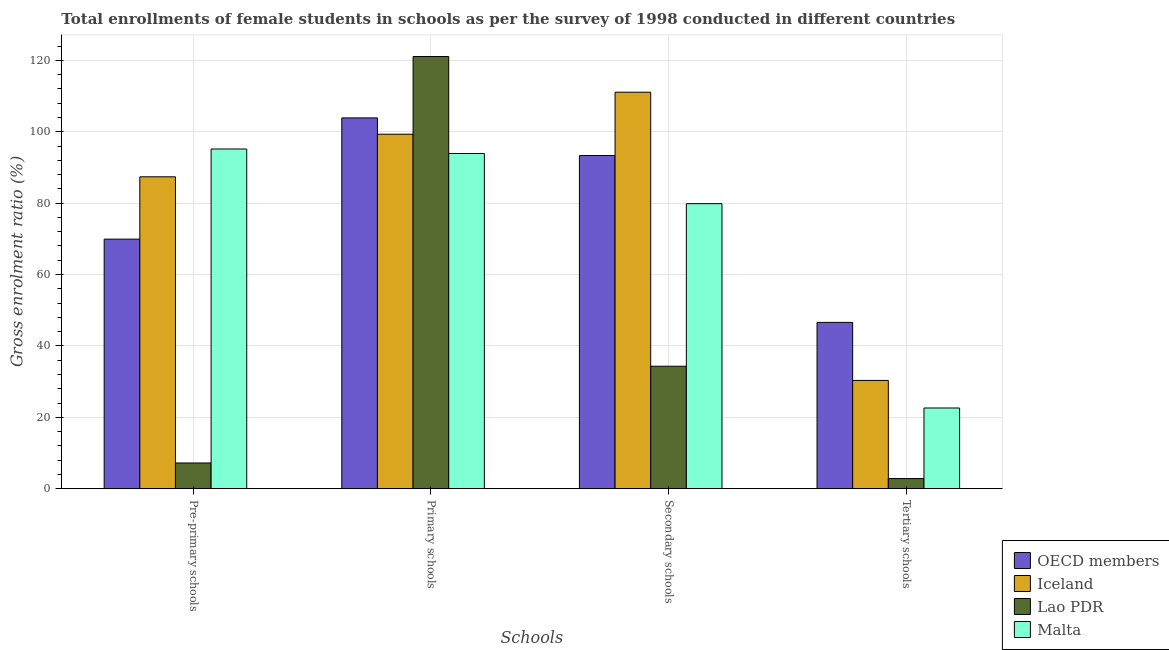How many groups of bars are there?
Offer a terse response. 4. Are the number of bars per tick equal to the number of legend labels?
Make the answer very short. Yes. Are the number of bars on each tick of the X-axis equal?
Provide a short and direct response. Yes. How many bars are there on the 4th tick from the left?
Provide a succinct answer. 4. How many bars are there on the 2nd tick from the right?
Make the answer very short. 4. What is the label of the 2nd group of bars from the left?
Your response must be concise. Primary schools. What is the gross enrolment ratio(female) in tertiary schools in Malta?
Ensure brevity in your answer.  22.6. Across all countries, what is the maximum gross enrolment ratio(female) in secondary schools?
Offer a terse response. 111.07. Across all countries, what is the minimum gross enrolment ratio(female) in tertiary schools?
Keep it short and to the point. 2.84. In which country was the gross enrolment ratio(female) in pre-primary schools maximum?
Offer a very short reply. Malta. In which country was the gross enrolment ratio(female) in primary schools minimum?
Your response must be concise. Malta. What is the total gross enrolment ratio(female) in primary schools in the graph?
Your answer should be compact. 418.17. What is the difference between the gross enrolment ratio(female) in tertiary schools in OECD members and that in Lao PDR?
Give a very brief answer. 43.74. What is the difference between the gross enrolment ratio(female) in pre-primary schools in OECD members and the gross enrolment ratio(female) in tertiary schools in Iceland?
Your response must be concise. 39.58. What is the average gross enrolment ratio(female) in primary schools per country?
Keep it short and to the point. 104.54. What is the difference between the gross enrolment ratio(female) in secondary schools and gross enrolment ratio(female) in tertiary schools in Malta?
Ensure brevity in your answer.  57.24. In how many countries, is the gross enrolment ratio(female) in tertiary schools greater than 88 %?
Your answer should be compact. 0. What is the ratio of the gross enrolment ratio(female) in primary schools in OECD members to that in Lao PDR?
Keep it short and to the point. 0.86. Is the gross enrolment ratio(female) in primary schools in Lao PDR less than that in Malta?
Keep it short and to the point. No. Is the difference between the gross enrolment ratio(female) in tertiary schools in Iceland and Malta greater than the difference between the gross enrolment ratio(female) in secondary schools in Iceland and Malta?
Make the answer very short. No. What is the difference between the highest and the second highest gross enrolment ratio(female) in tertiary schools?
Keep it short and to the point. 16.25. What is the difference between the highest and the lowest gross enrolment ratio(female) in secondary schools?
Make the answer very short. 76.77. Is it the case that in every country, the sum of the gross enrolment ratio(female) in tertiary schools and gross enrolment ratio(female) in secondary schools is greater than the sum of gross enrolment ratio(female) in pre-primary schools and gross enrolment ratio(female) in primary schools?
Ensure brevity in your answer.  No. What does the 2nd bar from the right in Pre-primary schools represents?
Provide a succinct answer. Lao PDR. Is it the case that in every country, the sum of the gross enrolment ratio(female) in pre-primary schools and gross enrolment ratio(female) in primary schools is greater than the gross enrolment ratio(female) in secondary schools?
Offer a very short reply. Yes. How many bars are there?
Provide a short and direct response. 16. What is the difference between two consecutive major ticks on the Y-axis?
Make the answer very short. 20. Are the values on the major ticks of Y-axis written in scientific E-notation?
Keep it short and to the point. No. Does the graph contain any zero values?
Make the answer very short. No. Where does the legend appear in the graph?
Offer a very short reply. Bottom right. How many legend labels are there?
Ensure brevity in your answer.  4. What is the title of the graph?
Make the answer very short. Total enrollments of female students in schools as per the survey of 1998 conducted in different countries. Does "Sierra Leone" appear as one of the legend labels in the graph?
Make the answer very short. No. What is the label or title of the X-axis?
Offer a terse response. Schools. What is the Gross enrolment ratio (%) in OECD members in Pre-primary schools?
Provide a short and direct response. 69.91. What is the Gross enrolment ratio (%) of Iceland in Pre-primary schools?
Ensure brevity in your answer.  87.37. What is the Gross enrolment ratio (%) in Lao PDR in Pre-primary schools?
Keep it short and to the point. 7.2. What is the Gross enrolment ratio (%) of Malta in Pre-primary schools?
Ensure brevity in your answer.  95.16. What is the Gross enrolment ratio (%) in OECD members in Primary schools?
Your response must be concise. 103.88. What is the Gross enrolment ratio (%) of Iceland in Primary schools?
Ensure brevity in your answer.  99.3. What is the Gross enrolment ratio (%) of Lao PDR in Primary schools?
Keep it short and to the point. 121.08. What is the Gross enrolment ratio (%) in Malta in Primary schools?
Your response must be concise. 93.9. What is the Gross enrolment ratio (%) of OECD members in Secondary schools?
Your answer should be very brief. 93.33. What is the Gross enrolment ratio (%) of Iceland in Secondary schools?
Provide a short and direct response. 111.07. What is the Gross enrolment ratio (%) in Lao PDR in Secondary schools?
Give a very brief answer. 34.3. What is the Gross enrolment ratio (%) in Malta in Secondary schools?
Provide a short and direct response. 79.85. What is the Gross enrolment ratio (%) of OECD members in Tertiary schools?
Give a very brief answer. 46.58. What is the Gross enrolment ratio (%) of Iceland in Tertiary schools?
Provide a short and direct response. 30.33. What is the Gross enrolment ratio (%) of Lao PDR in Tertiary schools?
Give a very brief answer. 2.84. What is the Gross enrolment ratio (%) of Malta in Tertiary schools?
Give a very brief answer. 22.6. Across all Schools, what is the maximum Gross enrolment ratio (%) in OECD members?
Provide a succinct answer. 103.88. Across all Schools, what is the maximum Gross enrolment ratio (%) in Iceland?
Provide a succinct answer. 111.07. Across all Schools, what is the maximum Gross enrolment ratio (%) of Lao PDR?
Offer a very short reply. 121.08. Across all Schools, what is the maximum Gross enrolment ratio (%) of Malta?
Your answer should be very brief. 95.16. Across all Schools, what is the minimum Gross enrolment ratio (%) of OECD members?
Offer a very short reply. 46.58. Across all Schools, what is the minimum Gross enrolment ratio (%) in Iceland?
Offer a terse response. 30.33. Across all Schools, what is the minimum Gross enrolment ratio (%) of Lao PDR?
Your response must be concise. 2.84. Across all Schools, what is the minimum Gross enrolment ratio (%) of Malta?
Offer a very short reply. 22.6. What is the total Gross enrolment ratio (%) of OECD members in the graph?
Provide a succinct answer. 313.7. What is the total Gross enrolment ratio (%) in Iceland in the graph?
Keep it short and to the point. 328.07. What is the total Gross enrolment ratio (%) in Lao PDR in the graph?
Give a very brief answer. 165.42. What is the total Gross enrolment ratio (%) of Malta in the graph?
Your response must be concise. 291.52. What is the difference between the Gross enrolment ratio (%) of OECD members in Pre-primary schools and that in Primary schools?
Your response must be concise. -33.97. What is the difference between the Gross enrolment ratio (%) in Iceland in Pre-primary schools and that in Primary schools?
Your answer should be very brief. -11.93. What is the difference between the Gross enrolment ratio (%) of Lao PDR in Pre-primary schools and that in Primary schools?
Provide a succinct answer. -113.88. What is the difference between the Gross enrolment ratio (%) in Malta in Pre-primary schools and that in Primary schools?
Ensure brevity in your answer.  1.26. What is the difference between the Gross enrolment ratio (%) of OECD members in Pre-primary schools and that in Secondary schools?
Offer a very short reply. -23.42. What is the difference between the Gross enrolment ratio (%) of Iceland in Pre-primary schools and that in Secondary schools?
Give a very brief answer. -23.7. What is the difference between the Gross enrolment ratio (%) in Lao PDR in Pre-primary schools and that in Secondary schools?
Your answer should be compact. -27.1. What is the difference between the Gross enrolment ratio (%) in Malta in Pre-primary schools and that in Secondary schools?
Provide a succinct answer. 15.32. What is the difference between the Gross enrolment ratio (%) in OECD members in Pre-primary schools and that in Tertiary schools?
Provide a short and direct response. 23.33. What is the difference between the Gross enrolment ratio (%) in Iceland in Pre-primary schools and that in Tertiary schools?
Make the answer very short. 57.04. What is the difference between the Gross enrolment ratio (%) of Lao PDR in Pre-primary schools and that in Tertiary schools?
Make the answer very short. 4.36. What is the difference between the Gross enrolment ratio (%) in Malta in Pre-primary schools and that in Tertiary schools?
Your answer should be compact. 72.56. What is the difference between the Gross enrolment ratio (%) of OECD members in Primary schools and that in Secondary schools?
Ensure brevity in your answer.  10.55. What is the difference between the Gross enrolment ratio (%) of Iceland in Primary schools and that in Secondary schools?
Provide a succinct answer. -11.77. What is the difference between the Gross enrolment ratio (%) in Lao PDR in Primary schools and that in Secondary schools?
Give a very brief answer. 86.78. What is the difference between the Gross enrolment ratio (%) in Malta in Primary schools and that in Secondary schools?
Make the answer very short. 14.06. What is the difference between the Gross enrolment ratio (%) of OECD members in Primary schools and that in Tertiary schools?
Your answer should be compact. 57.29. What is the difference between the Gross enrolment ratio (%) in Iceland in Primary schools and that in Tertiary schools?
Keep it short and to the point. 68.98. What is the difference between the Gross enrolment ratio (%) in Lao PDR in Primary schools and that in Tertiary schools?
Ensure brevity in your answer.  118.24. What is the difference between the Gross enrolment ratio (%) of Malta in Primary schools and that in Tertiary schools?
Provide a short and direct response. 71.3. What is the difference between the Gross enrolment ratio (%) of OECD members in Secondary schools and that in Tertiary schools?
Offer a very short reply. 46.75. What is the difference between the Gross enrolment ratio (%) of Iceland in Secondary schools and that in Tertiary schools?
Give a very brief answer. 80.74. What is the difference between the Gross enrolment ratio (%) in Lao PDR in Secondary schools and that in Tertiary schools?
Give a very brief answer. 31.47. What is the difference between the Gross enrolment ratio (%) in Malta in Secondary schools and that in Tertiary schools?
Your answer should be compact. 57.24. What is the difference between the Gross enrolment ratio (%) of OECD members in Pre-primary schools and the Gross enrolment ratio (%) of Iceland in Primary schools?
Give a very brief answer. -29.4. What is the difference between the Gross enrolment ratio (%) in OECD members in Pre-primary schools and the Gross enrolment ratio (%) in Lao PDR in Primary schools?
Provide a short and direct response. -51.17. What is the difference between the Gross enrolment ratio (%) in OECD members in Pre-primary schools and the Gross enrolment ratio (%) in Malta in Primary schools?
Provide a short and direct response. -24. What is the difference between the Gross enrolment ratio (%) of Iceland in Pre-primary schools and the Gross enrolment ratio (%) of Lao PDR in Primary schools?
Provide a succinct answer. -33.71. What is the difference between the Gross enrolment ratio (%) of Iceland in Pre-primary schools and the Gross enrolment ratio (%) of Malta in Primary schools?
Your answer should be very brief. -6.53. What is the difference between the Gross enrolment ratio (%) of Lao PDR in Pre-primary schools and the Gross enrolment ratio (%) of Malta in Primary schools?
Your answer should be compact. -86.7. What is the difference between the Gross enrolment ratio (%) of OECD members in Pre-primary schools and the Gross enrolment ratio (%) of Iceland in Secondary schools?
Provide a succinct answer. -41.16. What is the difference between the Gross enrolment ratio (%) in OECD members in Pre-primary schools and the Gross enrolment ratio (%) in Lao PDR in Secondary schools?
Your answer should be very brief. 35.61. What is the difference between the Gross enrolment ratio (%) of OECD members in Pre-primary schools and the Gross enrolment ratio (%) of Malta in Secondary schools?
Offer a very short reply. -9.94. What is the difference between the Gross enrolment ratio (%) in Iceland in Pre-primary schools and the Gross enrolment ratio (%) in Lao PDR in Secondary schools?
Keep it short and to the point. 53.07. What is the difference between the Gross enrolment ratio (%) in Iceland in Pre-primary schools and the Gross enrolment ratio (%) in Malta in Secondary schools?
Your answer should be compact. 7.52. What is the difference between the Gross enrolment ratio (%) of Lao PDR in Pre-primary schools and the Gross enrolment ratio (%) of Malta in Secondary schools?
Offer a very short reply. -72.65. What is the difference between the Gross enrolment ratio (%) of OECD members in Pre-primary schools and the Gross enrolment ratio (%) of Iceland in Tertiary schools?
Offer a very short reply. 39.58. What is the difference between the Gross enrolment ratio (%) of OECD members in Pre-primary schools and the Gross enrolment ratio (%) of Lao PDR in Tertiary schools?
Offer a terse response. 67.07. What is the difference between the Gross enrolment ratio (%) in OECD members in Pre-primary schools and the Gross enrolment ratio (%) in Malta in Tertiary schools?
Keep it short and to the point. 47.31. What is the difference between the Gross enrolment ratio (%) of Iceland in Pre-primary schools and the Gross enrolment ratio (%) of Lao PDR in Tertiary schools?
Give a very brief answer. 84.53. What is the difference between the Gross enrolment ratio (%) in Iceland in Pre-primary schools and the Gross enrolment ratio (%) in Malta in Tertiary schools?
Give a very brief answer. 64.77. What is the difference between the Gross enrolment ratio (%) of Lao PDR in Pre-primary schools and the Gross enrolment ratio (%) of Malta in Tertiary schools?
Make the answer very short. -15.4. What is the difference between the Gross enrolment ratio (%) of OECD members in Primary schools and the Gross enrolment ratio (%) of Iceland in Secondary schools?
Offer a very short reply. -7.19. What is the difference between the Gross enrolment ratio (%) of OECD members in Primary schools and the Gross enrolment ratio (%) of Lao PDR in Secondary schools?
Make the answer very short. 69.57. What is the difference between the Gross enrolment ratio (%) in OECD members in Primary schools and the Gross enrolment ratio (%) in Malta in Secondary schools?
Your answer should be compact. 24.03. What is the difference between the Gross enrolment ratio (%) of Iceland in Primary schools and the Gross enrolment ratio (%) of Lao PDR in Secondary schools?
Provide a short and direct response. 65. What is the difference between the Gross enrolment ratio (%) of Iceland in Primary schools and the Gross enrolment ratio (%) of Malta in Secondary schools?
Provide a succinct answer. 19.46. What is the difference between the Gross enrolment ratio (%) in Lao PDR in Primary schools and the Gross enrolment ratio (%) in Malta in Secondary schools?
Make the answer very short. 41.23. What is the difference between the Gross enrolment ratio (%) in OECD members in Primary schools and the Gross enrolment ratio (%) in Iceland in Tertiary schools?
Offer a very short reply. 73.55. What is the difference between the Gross enrolment ratio (%) in OECD members in Primary schools and the Gross enrolment ratio (%) in Lao PDR in Tertiary schools?
Provide a short and direct response. 101.04. What is the difference between the Gross enrolment ratio (%) in OECD members in Primary schools and the Gross enrolment ratio (%) in Malta in Tertiary schools?
Your response must be concise. 81.27. What is the difference between the Gross enrolment ratio (%) in Iceland in Primary schools and the Gross enrolment ratio (%) in Lao PDR in Tertiary schools?
Give a very brief answer. 96.47. What is the difference between the Gross enrolment ratio (%) of Iceland in Primary schools and the Gross enrolment ratio (%) of Malta in Tertiary schools?
Your response must be concise. 76.7. What is the difference between the Gross enrolment ratio (%) of Lao PDR in Primary schools and the Gross enrolment ratio (%) of Malta in Tertiary schools?
Offer a terse response. 98.48. What is the difference between the Gross enrolment ratio (%) of OECD members in Secondary schools and the Gross enrolment ratio (%) of Iceland in Tertiary schools?
Your answer should be compact. 63. What is the difference between the Gross enrolment ratio (%) of OECD members in Secondary schools and the Gross enrolment ratio (%) of Lao PDR in Tertiary schools?
Keep it short and to the point. 90.49. What is the difference between the Gross enrolment ratio (%) in OECD members in Secondary schools and the Gross enrolment ratio (%) in Malta in Tertiary schools?
Keep it short and to the point. 70.73. What is the difference between the Gross enrolment ratio (%) of Iceland in Secondary schools and the Gross enrolment ratio (%) of Lao PDR in Tertiary schools?
Your response must be concise. 108.23. What is the difference between the Gross enrolment ratio (%) of Iceland in Secondary schools and the Gross enrolment ratio (%) of Malta in Tertiary schools?
Your answer should be compact. 88.47. What is the difference between the Gross enrolment ratio (%) of Lao PDR in Secondary schools and the Gross enrolment ratio (%) of Malta in Tertiary schools?
Provide a succinct answer. 11.7. What is the average Gross enrolment ratio (%) of OECD members per Schools?
Offer a terse response. 78.42. What is the average Gross enrolment ratio (%) of Iceland per Schools?
Offer a very short reply. 82.02. What is the average Gross enrolment ratio (%) in Lao PDR per Schools?
Offer a very short reply. 41.36. What is the average Gross enrolment ratio (%) in Malta per Schools?
Offer a very short reply. 72.88. What is the difference between the Gross enrolment ratio (%) of OECD members and Gross enrolment ratio (%) of Iceland in Pre-primary schools?
Keep it short and to the point. -17.46. What is the difference between the Gross enrolment ratio (%) of OECD members and Gross enrolment ratio (%) of Lao PDR in Pre-primary schools?
Make the answer very short. 62.71. What is the difference between the Gross enrolment ratio (%) in OECD members and Gross enrolment ratio (%) in Malta in Pre-primary schools?
Provide a succinct answer. -25.25. What is the difference between the Gross enrolment ratio (%) in Iceland and Gross enrolment ratio (%) in Lao PDR in Pre-primary schools?
Ensure brevity in your answer.  80.17. What is the difference between the Gross enrolment ratio (%) of Iceland and Gross enrolment ratio (%) of Malta in Pre-primary schools?
Give a very brief answer. -7.79. What is the difference between the Gross enrolment ratio (%) of Lao PDR and Gross enrolment ratio (%) of Malta in Pre-primary schools?
Ensure brevity in your answer.  -87.96. What is the difference between the Gross enrolment ratio (%) in OECD members and Gross enrolment ratio (%) in Iceland in Primary schools?
Provide a succinct answer. 4.57. What is the difference between the Gross enrolment ratio (%) in OECD members and Gross enrolment ratio (%) in Lao PDR in Primary schools?
Give a very brief answer. -17.2. What is the difference between the Gross enrolment ratio (%) in OECD members and Gross enrolment ratio (%) in Malta in Primary schools?
Offer a very short reply. 9.97. What is the difference between the Gross enrolment ratio (%) in Iceland and Gross enrolment ratio (%) in Lao PDR in Primary schools?
Your answer should be compact. -21.78. What is the difference between the Gross enrolment ratio (%) of Iceland and Gross enrolment ratio (%) of Malta in Primary schools?
Ensure brevity in your answer.  5.4. What is the difference between the Gross enrolment ratio (%) of Lao PDR and Gross enrolment ratio (%) of Malta in Primary schools?
Make the answer very short. 27.18. What is the difference between the Gross enrolment ratio (%) in OECD members and Gross enrolment ratio (%) in Iceland in Secondary schools?
Provide a short and direct response. -17.74. What is the difference between the Gross enrolment ratio (%) in OECD members and Gross enrolment ratio (%) in Lao PDR in Secondary schools?
Your answer should be very brief. 59.02. What is the difference between the Gross enrolment ratio (%) in OECD members and Gross enrolment ratio (%) in Malta in Secondary schools?
Give a very brief answer. 13.48. What is the difference between the Gross enrolment ratio (%) in Iceland and Gross enrolment ratio (%) in Lao PDR in Secondary schools?
Provide a succinct answer. 76.77. What is the difference between the Gross enrolment ratio (%) of Iceland and Gross enrolment ratio (%) of Malta in Secondary schools?
Ensure brevity in your answer.  31.22. What is the difference between the Gross enrolment ratio (%) in Lao PDR and Gross enrolment ratio (%) in Malta in Secondary schools?
Give a very brief answer. -45.54. What is the difference between the Gross enrolment ratio (%) of OECD members and Gross enrolment ratio (%) of Iceland in Tertiary schools?
Your answer should be compact. 16.25. What is the difference between the Gross enrolment ratio (%) in OECD members and Gross enrolment ratio (%) in Lao PDR in Tertiary schools?
Provide a succinct answer. 43.74. What is the difference between the Gross enrolment ratio (%) in OECD members and Gross enrolment ratio (%) in Malta in Tertiary schools?
Provide a succinct answer. 23.98. What is the difference between the Gross enrolment ratio (%) in Iceland and Gross enrolment ratio (%) in Lao PDR in Tertiary schools?
Give a very brief answer. 27.49. What is the difference between the Gross enrolment ratio (%) in Iceland and Gross enrolment ratio (%) in Malta in Tertiary schools?
Keep it short and to the point. 7.72. What is the difference between the Gross enrolment ratio (%) of Lao PDR and Gross enrolment ratio (%) of Malta in Tertiary schools?
Your answer should be very brief. -19.77. What is the ratio of the Gross enrolment ratio (%) in OECD members in Pre-primary schools to that in Primary schools?
Keep it short and to the point. 0.67. What is the ratio of the Gross enrolment ratio (%) in Iceland in Pre-primary schools to that in Primary schools?
Your answer should be very brief. 0.88. What is the ratio of the Gross enrolment ratio (%) in Lao PDR in Pre-primary schools to that in Primary schools?
Provide a succinct answer. 0.06. What is the ratio of the Gross enrolment ratio (%) in Malta in Pre-primary schools to that in Primary schools?
Your response must be concise. 1.01. What is the ratio of the Gross enrolment ratio (%) in OECD members in Pre-primary schools to that in Secondary schools?
Your answer should be compact. 0.75. What is the ratio of the Gross enrolment ratio (%) of Iceland in Pre-primary schools to that in Secondary schools?
Ensure brevity in your answer.  0.79. What is the ratio of the Gross enrolment ratio (%) in Lao PDR in Pre-primary schools to that in Secondary schools?
Your answer should be compact. 0.21. What is the ratio of the Gross enrolment ratio (%) in Malta in Pre-primary schools to that in Secondary schools?
Ensure brevity in your answer.  1.19. What is the ratio of the Gross enrolment ratio (%) in OECD members in Pre-primary schools to that in Tertiary schools?
Provide a succinct answer. 1.5. What is the ratio of the Gross enrolment ratio (%) of Iceland in Pre-primary schools to that in Tertiary schools?
Give a very brief answer. 2.88. What is the ratio of the Gross enrolment ratio (%) of Lao PDR in Pre-primary schools to that in Tertiary schools?
Provide a short and direct response. 2.54. What is the ratio of the Gross enrolment ratio (%) in Malta in Pre-primary schools to that in Tertiary schools?
Offer a very short reply. 4.21. What is the ratio of the Gross enrolment ratio (%) in OECD members in Primary schools to that in Secondary schools?
Provide a short and direct response. 1.11. What is the ratio of the Gross enrolment ratio (%) of Iceland in Primary schools to that in Secondary schools?
Provide a succinct answer. 0.89. What is the ratio of the Gross enrolment ratio (%) in Lao PDR in Primary schools to that in Secondary schools?
Provide a short and direct response. 3.53. What is the ratio of the Gross enrolment ratio (%) in Malta in Primary schools to that in Secondary schools?
Provide a succinct answer. 1.18. What is the ratio of the Gross enrolment ratio (%) of OECD members in Primary schools to that in Tertiary schools?
Provide a succinct answer. 2.23. What is the ratio of the Gross enrolment ratio (%) in Iceland in Primary schools to that in Tertiary schools?
Offer a terse response. 3.27. What is the ratio of the Gross enrolment ratio (%) in Lao PDR in Primary schools to that in Tertiary schools?
Keep it short and to the point. 42.67. What is the ratio of the Gross enrolment ratio (%) of Malta in Primary schools to that in Tertiary schools?
Offer a terse response. 4.15. What is the ratio of the Gross enrolment ratio (%) in OECD members in Secondary schools to that in Tertiary schools?
Offer a terse response. 2. What is the ratio of the Gross enrolment ratio (%) of Iceland in Secondary schools to that in Tertiary schools?
Offer a terse response. 3.66. What is the ratio of the Gross enrolment ratio (%) of Lao PDR in Secondary schools to that in Tertiary schools?
Your answer should be very brief. 12.09. What is the ratio of the Gross enrolment ratio (%) of Malta in Secondary schools to that in Tertiary schools?
Provide a short and direct response. 3.53. What is the difference between the highest and the second highest Gross enrolment ratio (%) in OECD members?
Offer a very short reply. 10.55. What is the difference between the highest and the second highest Gross enrolment ratio (%) of Iceland?
Give a very brief answer. 11.77. What is the difference between the highest and the second highest Gross enrolment ratio (%) in Lao PDR?
Make the answer very short. 86.78. What is the difference between the highest and the second highest Gross enrolment ratio (%) in Malta?
Offer a terse response. 1.26. What is the difference between the highest and the lowest Gross enrolment ratio (%) of OECD members?
Your answer should be compact. 57.29. What is the difference between the highest and the lowest Gross enrolment ratio (%) of Iceland?
Your response must be concise. 80.74. What is the difference between the highest and the lowest Gross enrolment ratio (%) of Lao PDR?
Your answer should be compact. 118.24. What is the difference between the highest and the lowest Gross enrolment ratio (%) in Malta?
Keep it short and to the point. 72.56. 